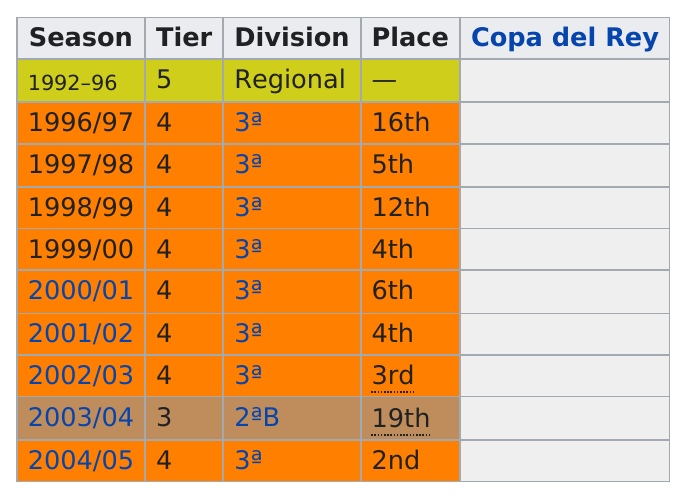Give some essential details in this illustration. The club's sole instance of placing fifth in a season occurred in 1997/1998. In 2003/2004, there was only one Tier 3. The club placed fourth in Tier 4 a total of two times. The location in which the last season was placed is 2nd. This team played in a regional division for one season. 